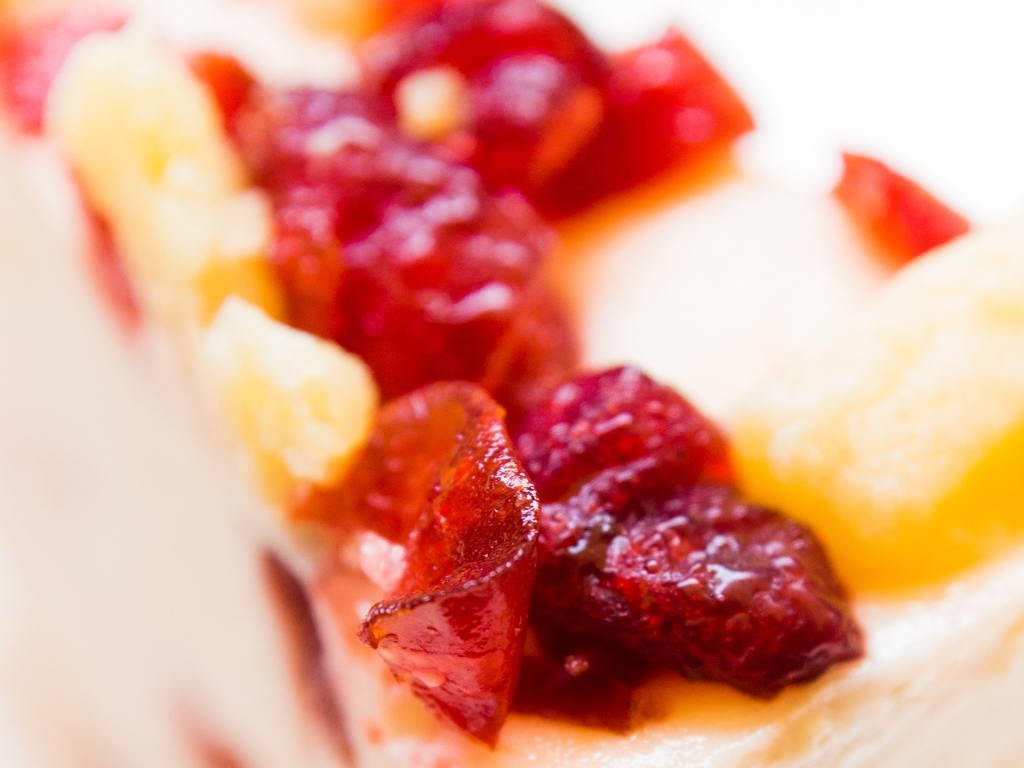What type of dessert is shown in the image? The image presents a close-up view of what seems to be a delectable cheesecake topped with an assortment of fresh fruits, including what appear to be strawberries and possibly peaches, offering a visual feast that suggests a delightful mix of creamy texture with the tart sweetness of the fruit. How might the texture contrast between the different components of the dessert affect the overall eating experience? The contrast between the creamy smoothness of the cheesecake and the soft yet slightly firmer texture of the fresh fruit toppings likely creates a layered mouthfeel. Each bite would offer the initial resistance of the fruit, followed by the rich and velvety cheese layer, then finishing with the crumbly, buttery base, providing a dynamic and pleasurable sensory experience. 